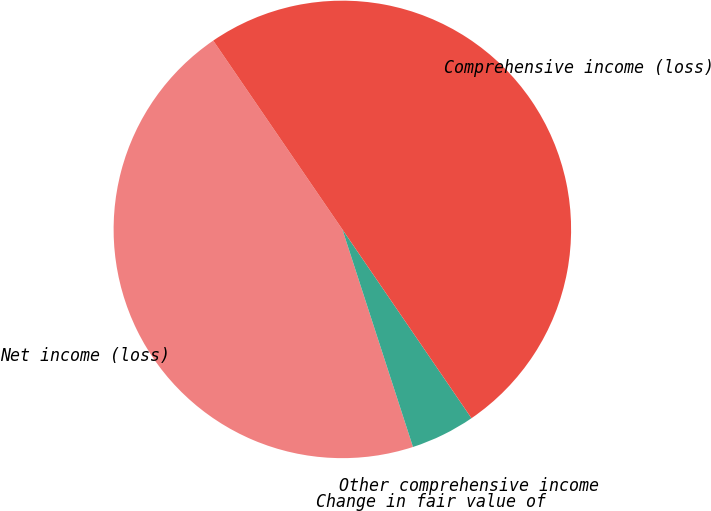<chart> <loc_0><loc_0><loc_500><loc_500><pie_chart><fcel>Net income (loss)<fcel>Change in fair value of<fcel>Other comprehensive income<fcel>Comprehensive income (loss)<nl><fcel>45.45%<fcel>0.0%<fcel>4.55%<fcel>50.0%<nl></chart> 